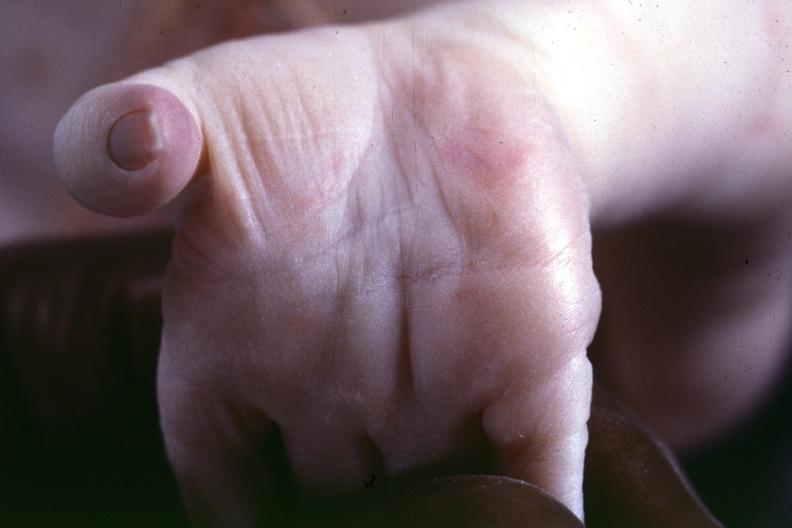does this image show source indicated?
Answer the question using a single word or phrase. Yes 